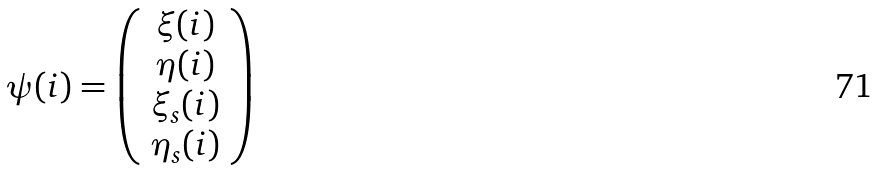Convert formula to latex. <formula><loc_0><loc_0><loc_500><loc_500>\psi ( i ) = \left ( \begin{array} { c } \xi ( i ) \\ \eta ( i ) \\ \xi _ { s } ( i ) \\ \eta _ { s } ( i ) \end{array} \right )</formula> 